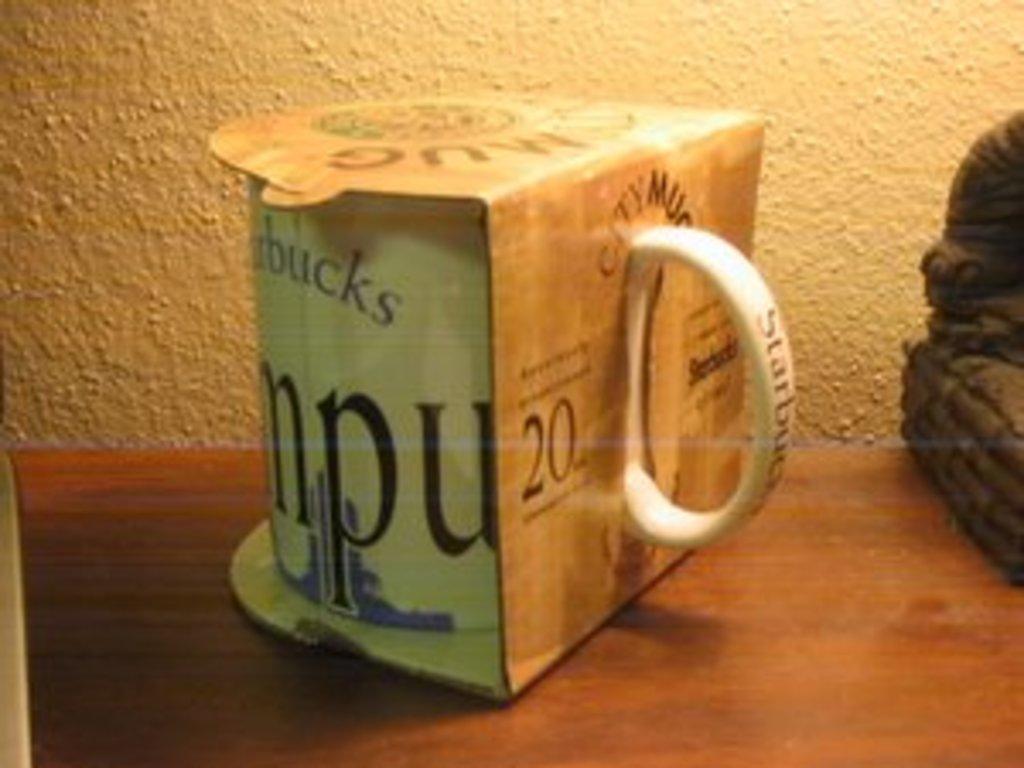What store is the mug from?
Offer a very short reply. Starbucks. What are the large words displayed?
Give a very brief answer. Starbucks. 